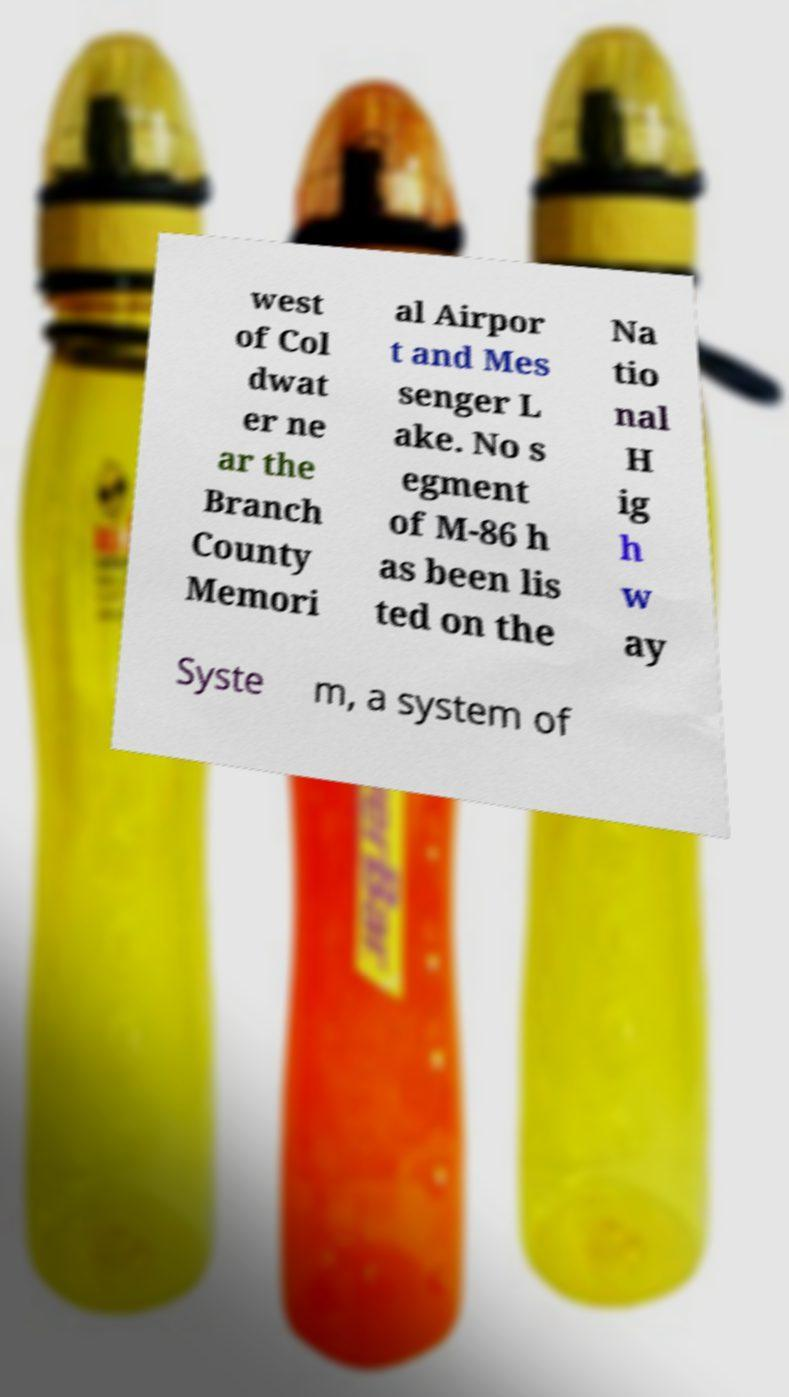Could you extract and type out the text from this image? west of Col dwat er ne ar the Branch County Memori al Airpor t and Mes senger L ake. No s egment of M-86 h as been lis ted on the Na tio nal H ig h w ay Syste m, a system of 